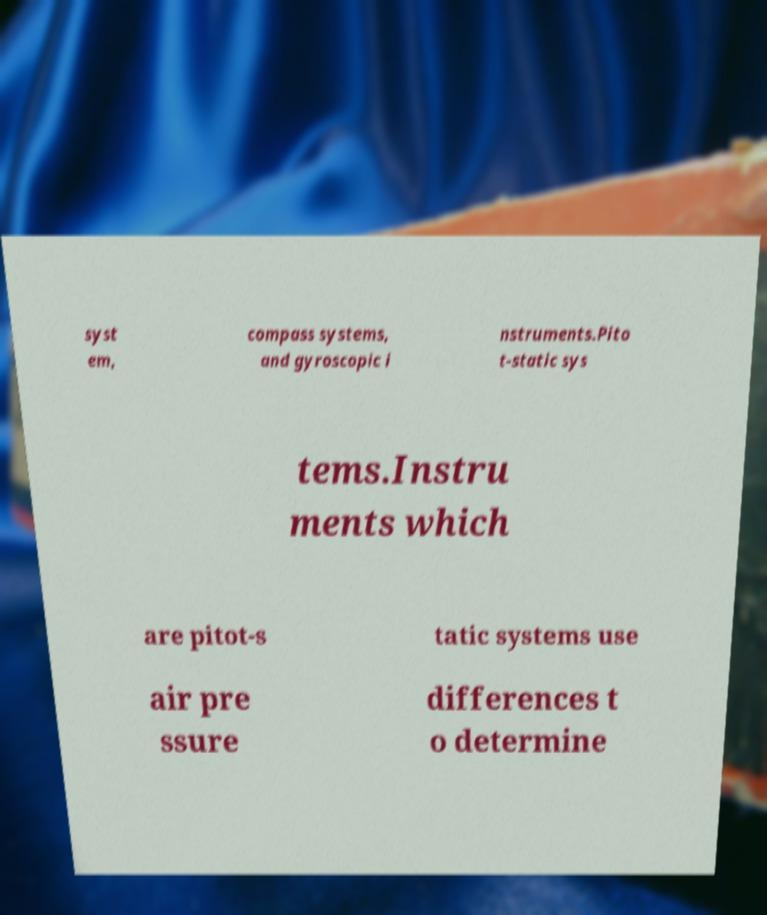Can you accurately transcribe the text from the provided image for me? syst em, compass systems, and gyroscopic i nstruments.Pito t-static sys tems.Instru ments which are pitot-s tatic systems use air pre ssure differences t o determine 